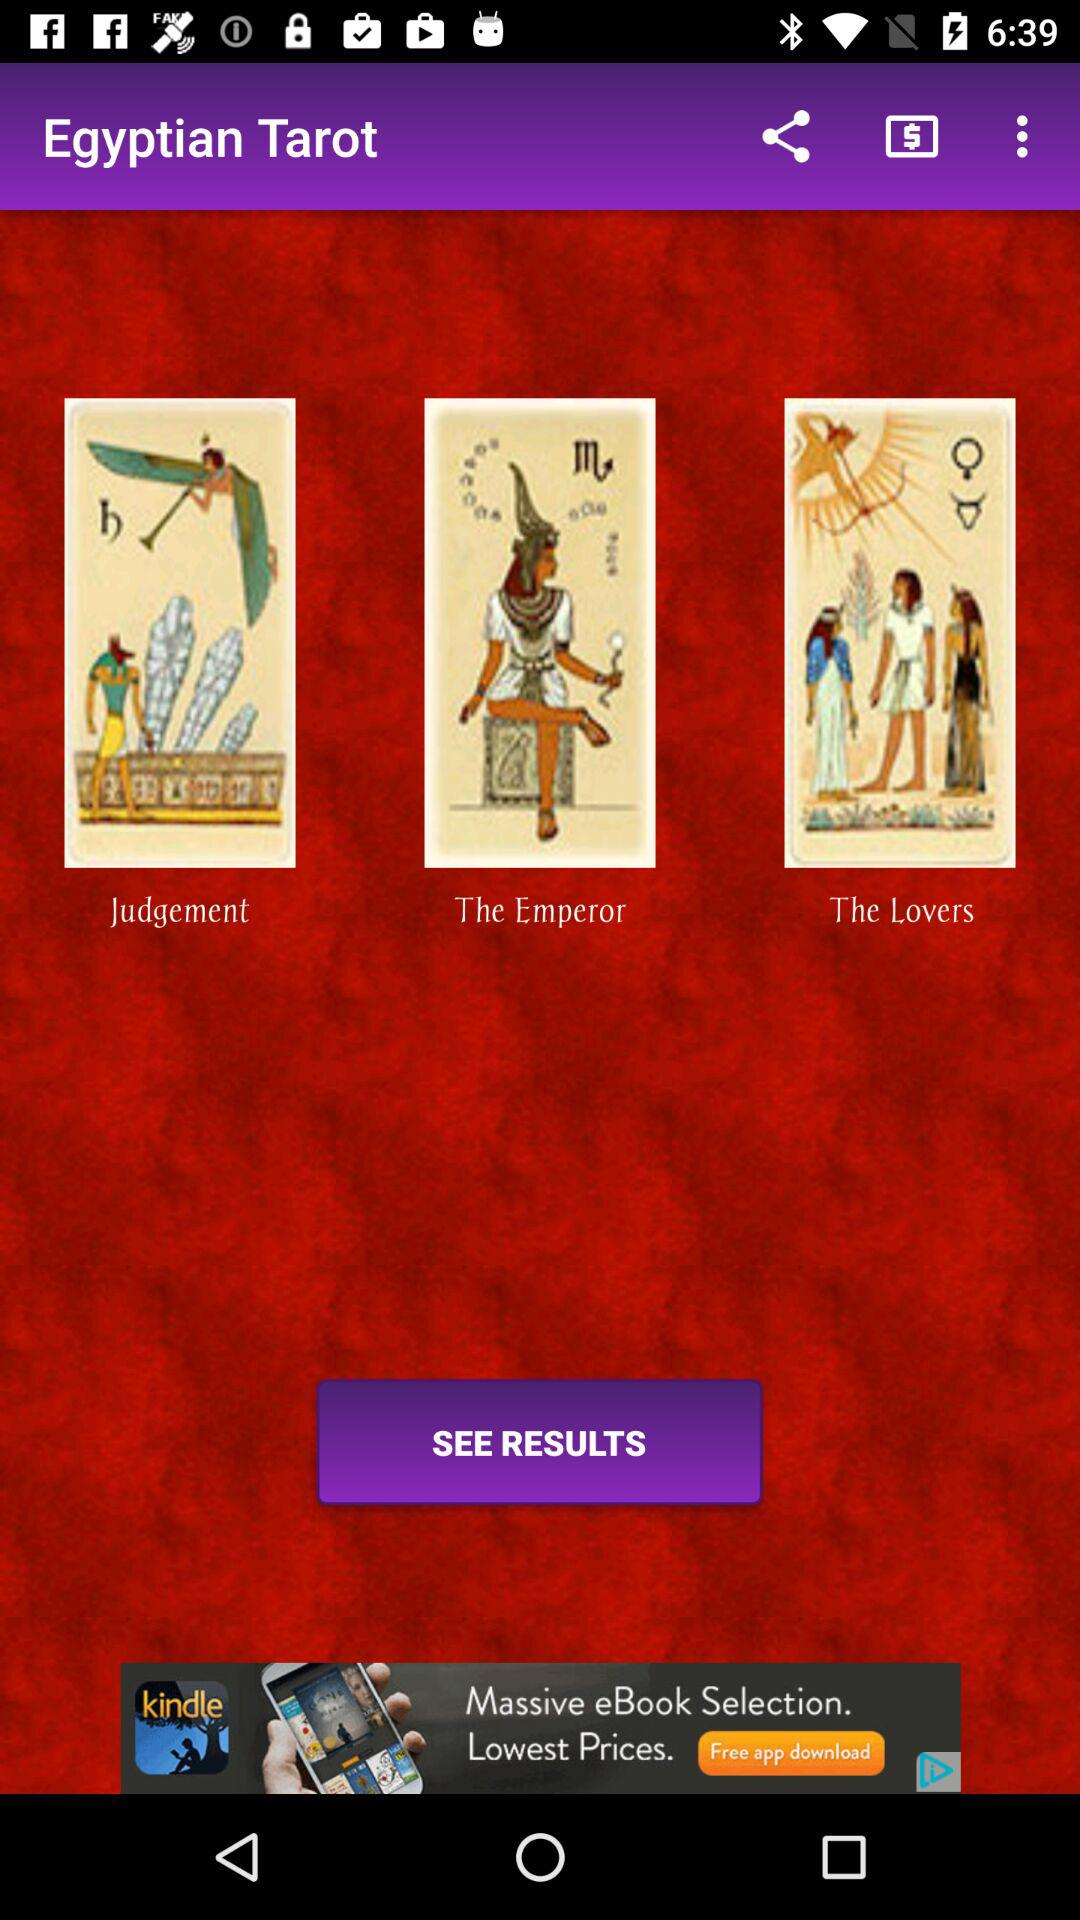How many results are there?
Answer the question using a single word or phrase. 3 